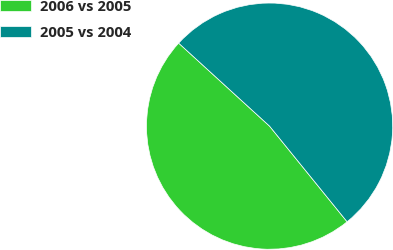Convert chart to OTSL. <chart><loc_0><loc_0><loc_500><loc_500><pie_chart><fcel>2006 vs 2005<fcel>2005 vs 2004<nl><fcel>47.62%<fcel>52.38%<nl></chart> 